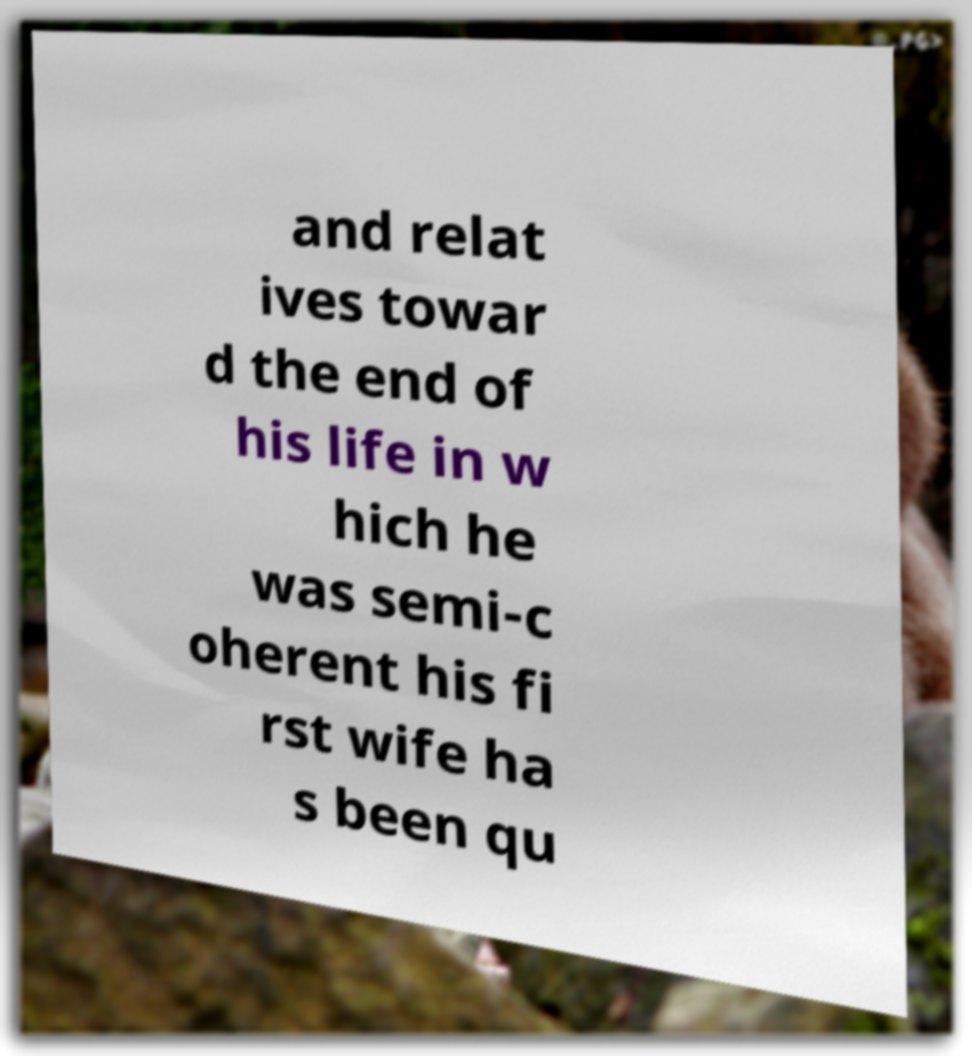There's text embedded in this image that I need extracted. Can you transcribe it verbatim? and relat ives towar d the end of his life in w hich he was semi-c oherent his fi rst wife ha s been qu 